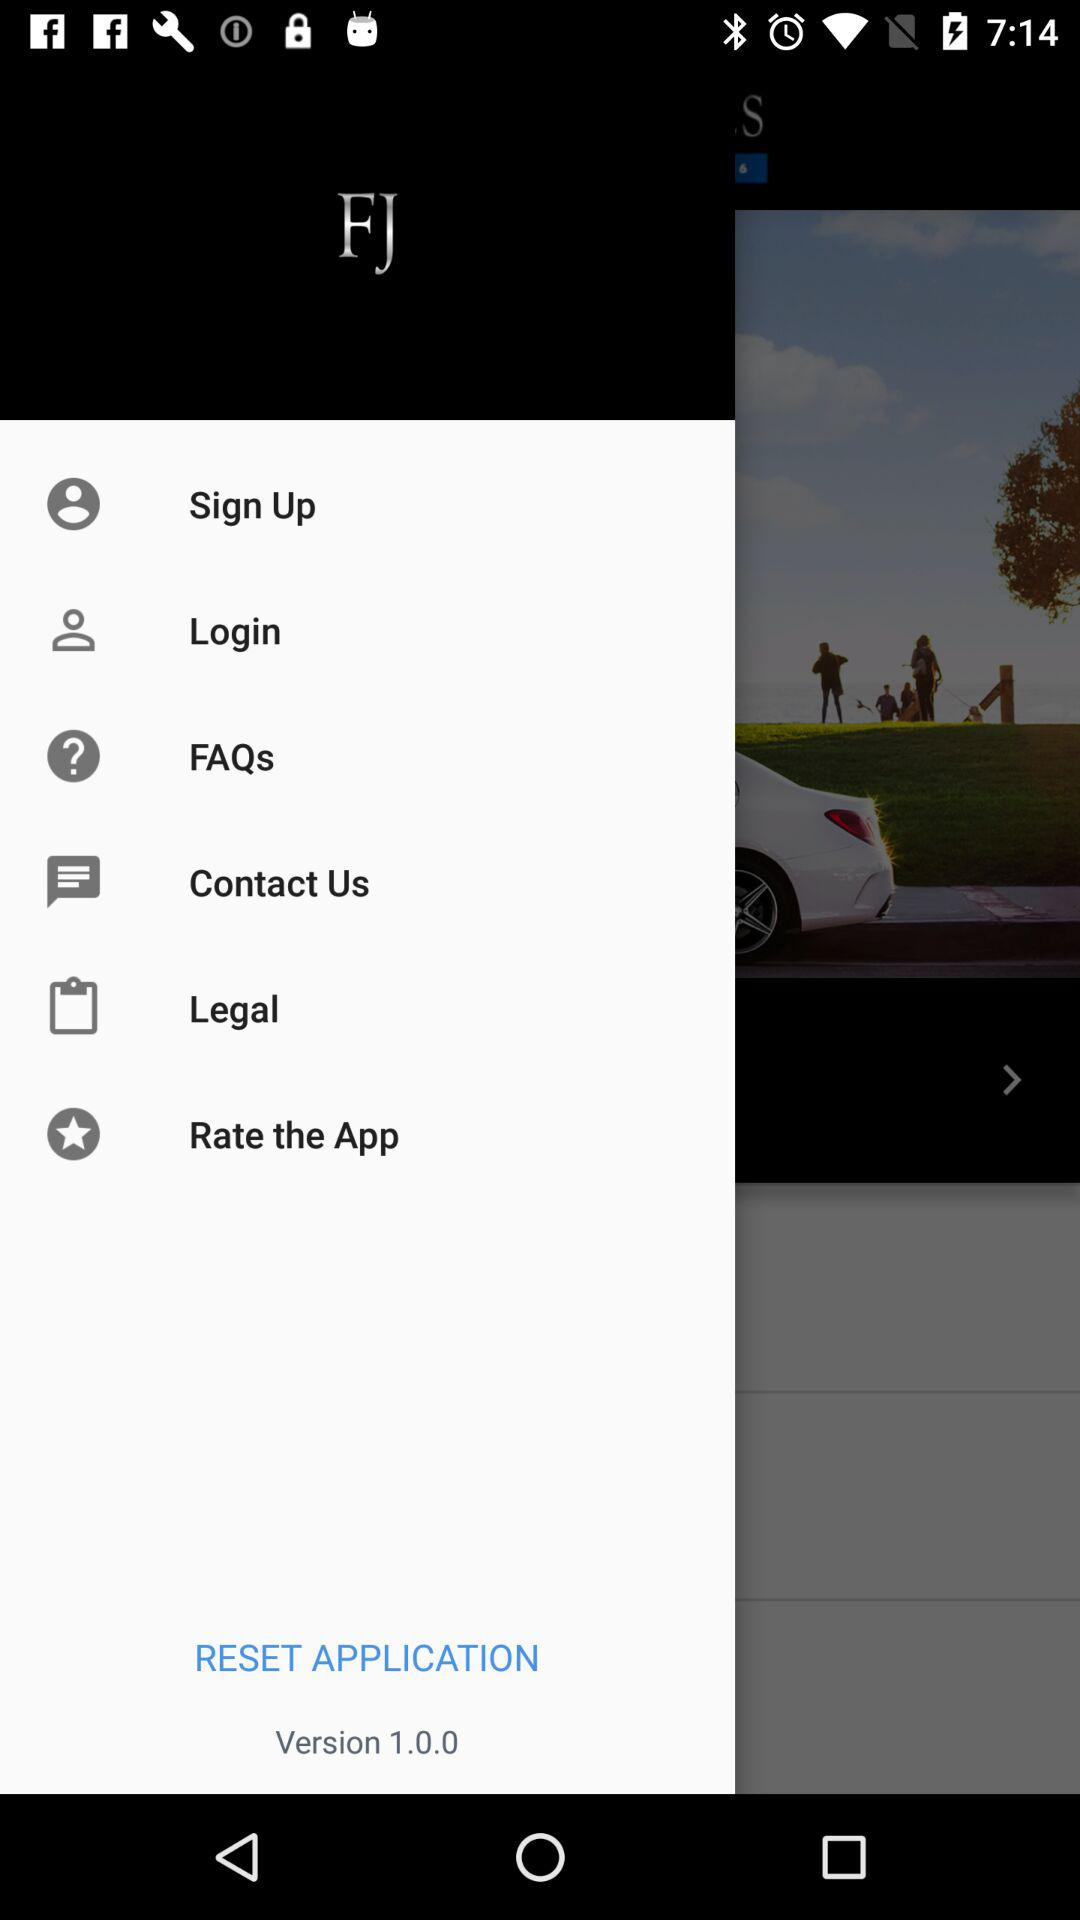What is the version of "FJ"? The version of "FJ" is 1.0.0. 